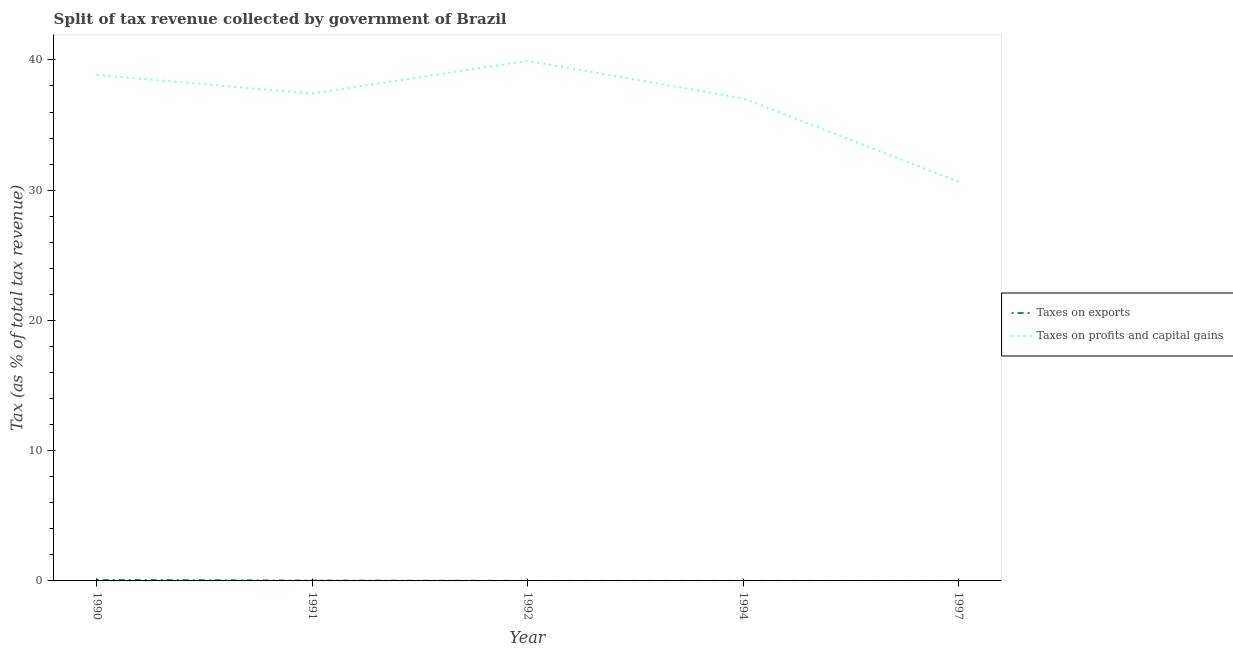How many different coloured lines are there?
Your answer should be very brief. 2. Does the line corresponding to percentage of revenue obtained from taxes on profits and capital gains intersect with the line corresponding to percentage of revenue obtained from taxes on exports?
Provide a succinct answer. No. What is the percentage of revenue obtained from taxes on profits and capital gains in 1990?
Provide a short and direct response. 38.85. Across all years, what is the maximum percentage of revenue obtained from taxes on exports?
Your response must be concise. 0.07. Across all years, what is the minimum percentage of revenue obtained from taxes on profits and capital gains?
Offer a very short reply. 30.65. In which year was the percentage of revenue obtained from taxes on profits and capital gains maximum?
Keep it short and to the point. 1992. What is the total percentage of revenue obtained from taxes on exports in the graph?
Your answer should be very brief. 0.11. What is the difference between the percentage of revenue obtained from taxes on profits and capital gains in 1991 and that in 1992?
Keep it short and to the point. -2.5. What is the difference between the percentage of revenue obtained from taxes on exports in 1997 and the percentage of revenue obtained from taxes on profits and capital gains in 1990?
Your answer should be compact. -38.85. What is the average percentage of revenue obtained from taxes on profits and capital gains per year?
Give a very brief answer. 36.78. In the year 1997, what is the difference between the percentage of revenue obtained from taxes on exports and percentage of revenue obtained from taxes on profits and capital gains?
Offer a very short reply. -30.65. What is the ratio of the percentage of revenue obtained from taxes on exports in 1992 to that in 1994?
Your answer should be very brief. 2. What is the difference between the highest and the second highest percentage of revenue obtained from taxes on exports?
Provide a short and direct response. 0.05. What is the difference between the highest and the lowest percentage of revenue obtained from taxes on profits and capital gains?
Keep it short and to the point. 9.27. In how many years, is the percentage of revenue obtained from taxes on profits and capital gains greater than the average percentage of revenue obtained from taxes on profits and capital gains taken over all years?
Ensure brevity in your answer.  4. Is the sum of the percentage of revenue obtained from taxes on profits and capital gains in 1990 and 1991 greater than the maximum percentage of revenue obtained from taxes on exports across all years?
Provide a short and direct response. Yes. Does the percentage of revenue obtained from taxes on exports monotonically increase over the years?
Your response must be concise. No. Is the percentage of revenue obtained from taxes on profits and capital gains strictly greater than the percentage of revenue obtained from taxes on exports over the years?
Make the answer very short. Yes. Is the percentage of revenue obtained from taxes on exports strictly less than the percentage of revenue obtained from taxes on profits and capital gains over the years?
Your answer should be very brief. Yes. How many lines are there?
Give a very brief answer. 2. Does the graph contain any zero values?
Your answer should be compact. No. Where does the legend appear in the graph?
Make the answer very short. Center right. How many legend labels are there?
Ensure brevity in your answer.  2. How are the legend labels stacked?
Your response must be concise. Vertical. What is the title of the graph?
Keep it short and to the point. Split of tax revenue collected by government of Brazil. Does "Merchandise exports" appear as one of the legend labels in the graph?
Your answer should be very brief. No. What is the label or title of the X-axis?
Provide a short and direct response. Year. What is the label or title of the Y-axis?
Keep it short and to the point. Tax (as % of total tax revenue). What is the Tax (as % of total tax revenue) in Taxes on exports in 1990?
Offer a very short reply. 0.07. What is the Tax (as % of total tax revenue) in Taxes on profits and capital gains in 1990?
Your answer should be very brief. 38.85. What is the Tax (as % of total tax revenue) of Taxes on exports in 1991?
Keep it short and to the point. 0.03. What is the Tax (as % of total tax revenue) of Taxes on profits and capital gains in 1991?
Your answer should be compact. 37.42. What is the Tax (as % of total tax revenue) in Taxes on exports in 1992?
Your answer should be very brief. 0. What is the Tax (as % of total tax revenue) of Taxes on profits and capital gains in 1992?
Give a very brief answer. 39.93. What is the Tax (as % of total tax revenue) of Taxes on exports in 1994?
Give a very brief answer. 0. What is the Tax (as % of total tax revenue) in Taxes on profits and capital gains in 1994?
Offer a terse response. 37.05. What is the Tax (as % of total tax revenue) of Taxes on exports in 1997?
Your answer should be compact. 0. What is the Tax (as % of total tax revenue) in Taxes on profits and capital gains in 1997?
Keep it short and to the point. 30.65. Across all years, what is the maximum Tax (as % of total tax revenue) in Taxes on exports?
Your answer should be very brief. 0.07. Across all years, what is the maximum Tax (as % of total tax revenue) in Taxes on profits and capital gains?
Offer a very short reply. 39.93. Across all years, what is the minimum Tax (as % of total tax revenue) in Taxes on exports?
Offer a terse response. 0. Across all years, what is the minimum Tax (as % of total tax revenue) of Taxes on profits and capital gains?
Your response must be concise. 30.65. What is the total Tax (as % of total tax revenue) in Taxes on exports in the graph?
Keep it short and to the point. 0.11. What is the total Tax (as % of total tax revenue) in Taxes on profits and capital gains in the graph?
Offer a very short reply. 183.9. What is the difference between the Tax (as % of total tax revenue) in Taxes on exports in 1990 and that in 1991?
Keep it short and to the point. 0.05. What is the difference between the Tax (as % of total tax revenue) of Taxes on profits and capital gains in 1990 and that in 1991?
Provide a succinct answer. 1.43. What is the difference between the Tax (as % of total tax revenue) in Taxes on exports in 1990 and that in 1992?
Make the answer very short. 0.07. What is the difference between the Tax (as % of total tax revenue) in Taxes on profits and capital gains in 1990 and that in 1992?
Your answer should be very brief. -1.08. What is the difference between the Tax (as % of total tax revenue) in Taxes on exports in 1990 and that in 1994?
Ensure brevity in your answer.  0.07. What is the difference between the Tax (as % of total tax revenue) of Taxes on profits and capital gains in 1990 and that in 1994?
Your answer should be very brief. 1.8. What is the difference between the Tax (as % of total tax revenue) of Taxes on exports in 1990 and that in 1997?
Keep it short and to the point. 0.07. What is the difference between the Tax (as % of total tax revenue) of Taxes on profits and capital gains in 1990 and that in 1997?
Provide a succinct answer. 8.2. What is the difference between the Tax (as % of total tax revenue) of Taxes on exports in 1991 and that in 1992?
Make the answer very short. 0.02. What is the difference between the Tax (as % of total tax revenue) in Taxes on profits and capital gains in 1991 and that in 1992?
Your answer should be compact. -2.5. What is the difference between the Tax (as % of total tax revenue) of Taxes on exports in 1991 and that in 1994?
Offer a very short reply. 0.03. What is the difference between the Tax (as % of total tax revenue) in Taxes on profits and capital gains in 1991 and that in 1994?
Give a very brief answer. 0.37. What is the difference between the Tax (as % of total tax revenue) in Taxes on exports in 1991 and that in 1997?
Make the answer very short. 0.02. What is the difference between the Tax (as % of total tax revenue) of Taxes on profits and capital gains in 1991 and that in 1997?
Provide a short and direct response. 6.77. What is the difference between the Tax (as % of total tax revenue) in Taxes on profits and capital gains in 1992 and that in 1994?
Offer a very short reply. 2.87. What is the difference between the Tax (as % of total tax revenue) in Taxes on exports in 1992 and that in 1997?
Ensure brevity in your answer.  -0. What is the difference between the Tax (as % of total tax revenue) of Taxes on profits and capital gains in 1992 and that in 1997?
Give a very brief answer. 9.27. What is the difference between the Tax (as % of total tax revenue) of Taxes on exports in 1994 and that in 1997?
Your answer should be compact. -0. What is the difference between the Tax (as % of total tax revenue) in Taxes on profits and capital gains in 1994 and that in 1997?
Your answer should be very brief. 6.4. What is the difference between the Tax (as % of total tax revenue) in Taxes on exports in 1990 and the Tax (as % of total tax revenue) in Taxes on profits and capital gains in 1991?
Keep it short and to the point. -37.35. What is the difference between the Tax (as % of total tax revenue) of Taxes on exports in 1990 and the Tax (as % of total tax revenue) of Taxes on profits and capital gains in 1992?
Provide a succinct answer. -39.85. What is the difference between the Tax (as % of total tax revenue) in Taxes on exports in 1990 and the Tax (as % of total tax revenue) in Taxes on profits and capital gains in 1994?
Provide a short and direct response. -36.98. What is the difference between the Tax (as % of total tax revenue) of Taxes on exports in 1990 and the Tax (as % of total tax revenue) of Taxes on profits and capital gains in 1997?
Provide a succinct answer. -30.58. What is the difference between the Tax (as % of total tax revenue) of Taxes on exports in 1991 and the Tax (as % of total tax revenue) of Taxes on profits and capital gains in 1992?
Make the answer very short. -39.9. What is the difference between the Tax (as % of total tax revenue) in Taxes on exports in 1991 and the Tax (as % of total tax revenue) in Taxes on profits and capital gains in 1994?
Your answer should be very brief. -37.03. What is the difference between the Tax (as % of total tax revenue) in Taxes on exports in 1991 and the Tax (as % of total tax revenue) in Taxes on profits and capital gains in 1997?
Your response must be concise. -30.63. What is the difference between the Tax (as % of total tax revenue) in Taxes on exports in 1992 and the Tax (as % of total tax revenue) in Taxes on profits and capital gains in 1994?
Your answer should be compact. -37.05. What is the difference between the Tax (as % of total tax revenue) of Taxes on exports in 1992 and the Tax (as % of total tax revenue) of Taxes on profits and capital gains in 1997?
Make the answer very short. -30.65. What is the difference between the Tax (as % of total tax revenue) of Taxes on exports in 1994 and the Tax (as % of total tax revenue) of Taxes on profits and capital gains in 1997?
Offer a terse response. -30.65. What is the average Tax (as % of total tax revenue) in Taxes on exports per year?
Your response must be concise. 0.02. What is the average Tax (as % of total tax revenue) in Taxes on profits and capital gains per year?
Keep it short and to the point. 36.78. In the year 1990, what is the difference between the Tax (as % of total tax revenue) of Taxes on exports and Tax (as % of total tax revenue) of Taxes on profits and capital gains?
Provide a short and direct response. -38.78. In the year 1991, what is the difference between the Tax (as % of total tax revenue) of Taxes on exports and Tax (as % of total tax revenue) of Taxes on profits and capital gains?
Ensure brevity in your answer.  -37.4. In the year 1992, what is the difference between the Tax (as % of total tax revenue) in Taxes on exports and Tax (as % of total tax revenue) in Taxes on profits and capital gains?
Provide a short and direct response. -39.92. In the year 1994, what is the difference between the Tax (as % of total tax revenue) in Taxes on exports and Tax (as % of total tax revenue) in Taxes on profits and capital gains?
Ensure brevity in your answer.  -37.05. In the year 1997, what is the difference between the Tax (as % of total tax revenue) in Taxes on exports and Tax (as % of total tax revenue) in Taxes on profits and capital gains?
Your response must be concise. -30.65. What is the ratio of the Tax (as % of total tax revenue) in Taxes on exports in 1990 to that in 1991?
Ensure brevity in your answer.  2.76. What is the ratio of the Tax (as % of total tax revenue) in Taxes on profits and capital gains in 1990 to that in 1991?
Your response must be concise. 1.04. What is the ratio of the Tax (as % of total tax revenue) in Taxes on exports in 1990 to that in 1992?
Offer a terse response. 38.17. What is the ratio of the Tax (as % of total tax revenue) of Taxes on profits and capital gains in 1990 to that in 1992?
Give a very brief answer. 0.97. What is the ratio of the Tax (as % of total tax revenue) of Taxes on exports in 1990 to that in 1994?
Make the answer very short. 76.24. What is the ratio of the Tax (as % of total tax revenue) in Taxes on profits and capital gains in 1990 to that in 1994?
Offer a very short reply. 1.05. What is the ratio of the Tax (as % of total tax revenue) of Taxes on exports in 1990 to that in 1997?
Ensure brevity in your answer.  24.57. What is the ratio of the Tax (as % of total tax revenue) in Taxes on profits and capital gains in 1990 to that in 1997?
Provide a succinct answer. 1.27. What is the ratio of the Tax (as % of total tax revenue) of Taxes on exports in 1991 to that in 1992?
Keep it short and to the point. 13.82. What is the ratio of the Tax (as % of total tax revenue) of Taxes on profits and capital gains in 1991 to that in 1992?
Your answer should be very brief. 0.94. What is the ratio of the Tax (as % of total tax revenue) of Taxes on exports in 1991 to that in 1994?
Your response must be concise. 27.61. What is the ratio of the Tax (as % of total tax revenue) in Taxes on profits and capital gains in 1991 to that in 1994?
Offer a terse response. 1.01. What is the ratio of the Tax (as % of total tax revenue) in Taxes on exports in 1991 to that in 1997?
Your answer should be compact. 8.9. What is the ratio of the Tax (as % of total tax revenue) in Taxes on profits and capital gains in 1991 to that in 1997?
Offer a terse response. 1.22. What is the ratio of the Tax (as % of total tax revenue) in Taxes on exports in 1992 to that in 1994?
Ensure brevity in your answer.  2. What is the ratio of the Tax (as % of total tax revenue) in Taxes on profits and capital gains in 1992 to that in 1994?
Offer a terse response. 1.08. What is the ratio of the Tax (as % of total tax revenue) of Taxes on exports in 1992 to that in 1997?
Offer a very short reply. 0.64. What is the ratio of the Tax (as % of total tax revenue) in Taxes on profits and capital gains in 1992 to that in 1997?
Your answer should be very brief. 1.3. What is the ratio of the Tax (as % of total tax revenue) of Taxes on exports in 1994 to that in 1997?
Provide a succinct answer. 0.32. What is the ratio of the Tax (as % of total tax revenue) in Taxes on profits and capital gains in 1994 to that in 1997?
Keep it short and to the point. 1.21. What is the difference between the highest and the second highest Tax (as % of total tax revenue) in Taxes on exports?
Your response must be concise. 0.05. What is the difference between the highest and the second highest Tax (as % of total tax revenue) of Taxes on profits and capital gains?
Provide a short and direct response. 1.08. What is the difference between the highest and the lowest Tax (as % of total tax revenue) in Taxes on exports?
Your response must be concise. 0.07. What is the difference between the highest and the lowest Tax (as % of total tax revenue) of Taxes on profits and capital gains?
Ensure brevity in your answer.  9.27. 